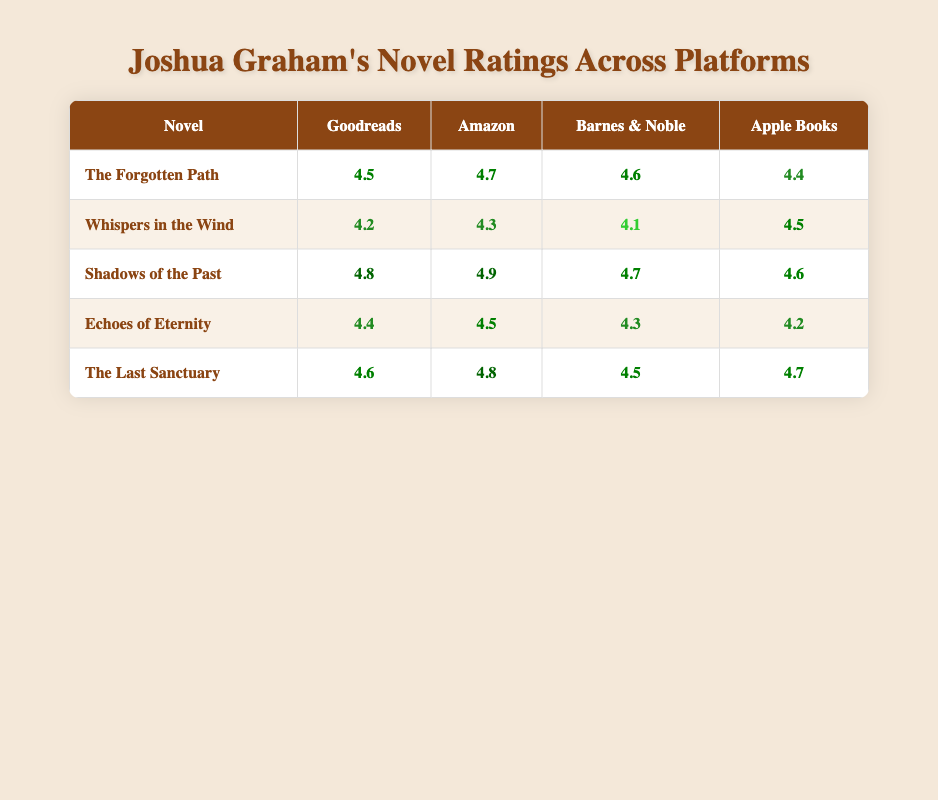What is the average rating of "Shadows of the Past" across all platforms? The ratings for "Shadows of the Past" are as follows: Goodreads (4.8), Amazon (4.9), Barnes & Noble (4.7), and Apple Books (4.6). To find the average, sum these ratings: 4.8 + 4.9 + 4.7 + 4.6 = 19. The number of platforms is 4, so the average is 19 / 4 = 4.75.
Answer: 4.75 Which platform has the highest rating for "The Last Sanctuary"? The ratings for "The Last Sanctuary" on each platform are: Goodreads (4.6), Amazon (4.8), Barnes & Noble (4.5), and Apple Books (4.7). Comparing these, the highest rating is on Amazon at 4.8.
Answer: Amazon Is the rating of "Whispers in the Wind" higher on Apple Books than on Goodreads? The rating for "Whispers in the Wind" on Apple Books is 4.5, while on Goodreads it is 4.2. Since 4.5 > 4.2, the rating on Apple Books is higher.
Answer: Yes What is the overall highest rating across all novels and platforms? The highest individual ratings for each novel are: "The Forgotten Path" (4.7 on Amazon), "Whispers in the Wind" (4.5 on Apple Books), "Shadows of the Past" (4.9 on Amazon), "Echoes of Eternity" (4.5 on Amazon), and "The Last Sanctuary" (4.8 on Amazon). The highest of these is 4.9 from "Shadows of the Past" on Amazon.
Answer: 4.9 Which novel has the lowest average rating across all platforms? The average ratings calculated per novel are: "The Forgotten Path" (4.55), "Whispers in the Wind" (4.27), "Shadows of the Past" (4.75), "Echoes of Eternity" (4.35), and "The Last Sanctuary" (4.66). The lowest average rating is for "Whispers in the Wind" at 4.27.
Answer: Whispers in the Wind 